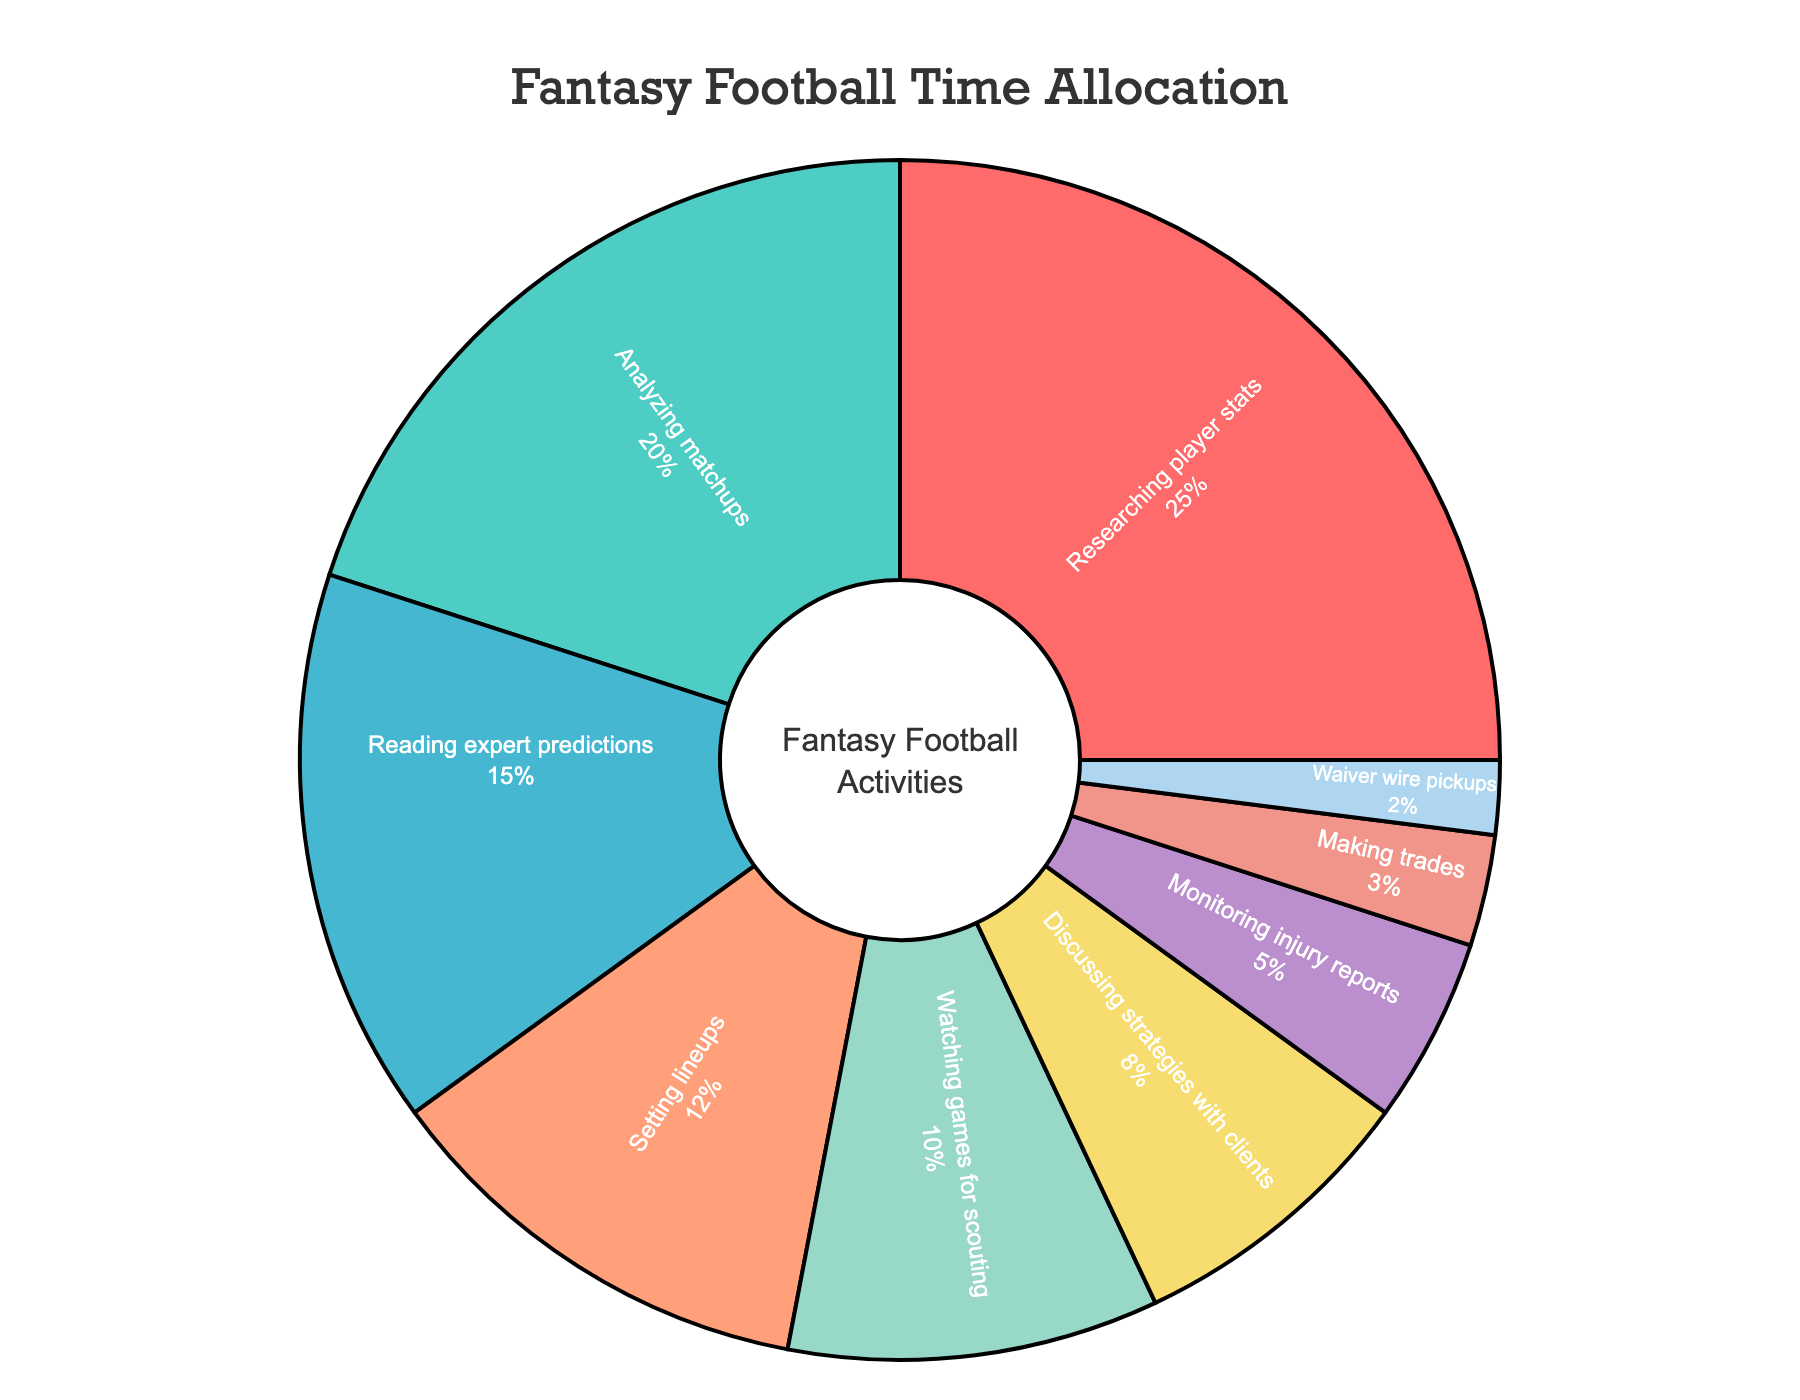What is the largest activity slice in the pie chart? To determine the largest activity slice, look for the segment with the highest percentage value. The "Researching player stats" slice is labeled with 25%, which is the highest percentage in the chart.
Answer: Researching player stats Which activities combined make up exactly 50% of the time spent? Combining "Researching player stats" and "Analyzing matchups" will give you 25% + 20%. Adding these two values equals 45%. Next, add "Reading expert predictions" which is 15%. But since this will exceed 50%, choose "Setting lineups" 12% instead. Hence required activities are "Researching player stats" 25%, "Analyzing matchups" 20% and "Setting lineups" 12%.
Answer: Researching player stats, Analyzing matchups, and Setting lineups Which activity takes the least amount of time? The smallest segment in the pie chart is observed and tagged to the activity with the lowest percentage, which is "Waiver wire pickups" at 2%.
Answer: Waiver wire pickups How much more time is spent on "Watching games for scouting" compared to "Monitoring injury reports"? The given values are 10% for "Watching games for scouting" and 5% for "Monitoring injury reports". Subtract 5% from 10% to get the difference.
Answer: 5% What is the combined percentage of time spent on "Discussing strategies with clients" and "Making trades"? The percentages for "Discussing strategies with clients" and "Making trades" are 8% and 3% respectively. Adding these two, 8% + 3%, totals to 11%.
Answer: 11% Which activity slice is colored green in the chart? By referring to the color assignment in the pie chart, the green color corresponds to the "Analyzing matchups" activity.
Answer: Analyzing matchups Is more time spent on "Reading expert predictions" or "Setting lineups"? Compare the given values, which are 15% for "Reading expert predictions" and 12% for "Setting lineups". 15% is greater than 12%.
Answer: Reading expert predictions Which two activities combined have the same time allocation as "Researching player stats"? "Researching player stats" has a 25% allocation. Combining "Watching games for scouting" (10%) and "Setting lineups" (12%) gives 10% + 12% = 22%. Including "Waiver wire pickups" (2%) to it makes it 24%. However, adding "Monitoring injury reports" (5%) will exceed the 25%. So, "Analyzing matchups" (20%) and "Making trades"(3%) yields 20% + 3% = 23%. Hence choose "Analyzing matchups" 20% and "Reading expert predictions" 15% yields 20% + 15% = 35%. Therefore search continues as none works.
Answer: No combination exactly equals "Researching player stats" What percentage of time is spent on activities other than "Researching player stats" and "Analyzing matchups"? Add the percentages of all other activities than these two, which are: 15% + 12% + 10% + 8% + 5% + 3% + 2%. This calculated as 55%. Subtracting 25% + 20% totals to 45%
Answer: 55% Which are the three smallest activities in terms of time allocation? By identifying the three smallest slices in the pie chart, these appear to be "Waiver wire pickups" (2%), "Making trades" (3%), and "Monitoring injury reports" (5%).
Answer: Waiver wire pickups, Making trades, and Monitoring injury reports 